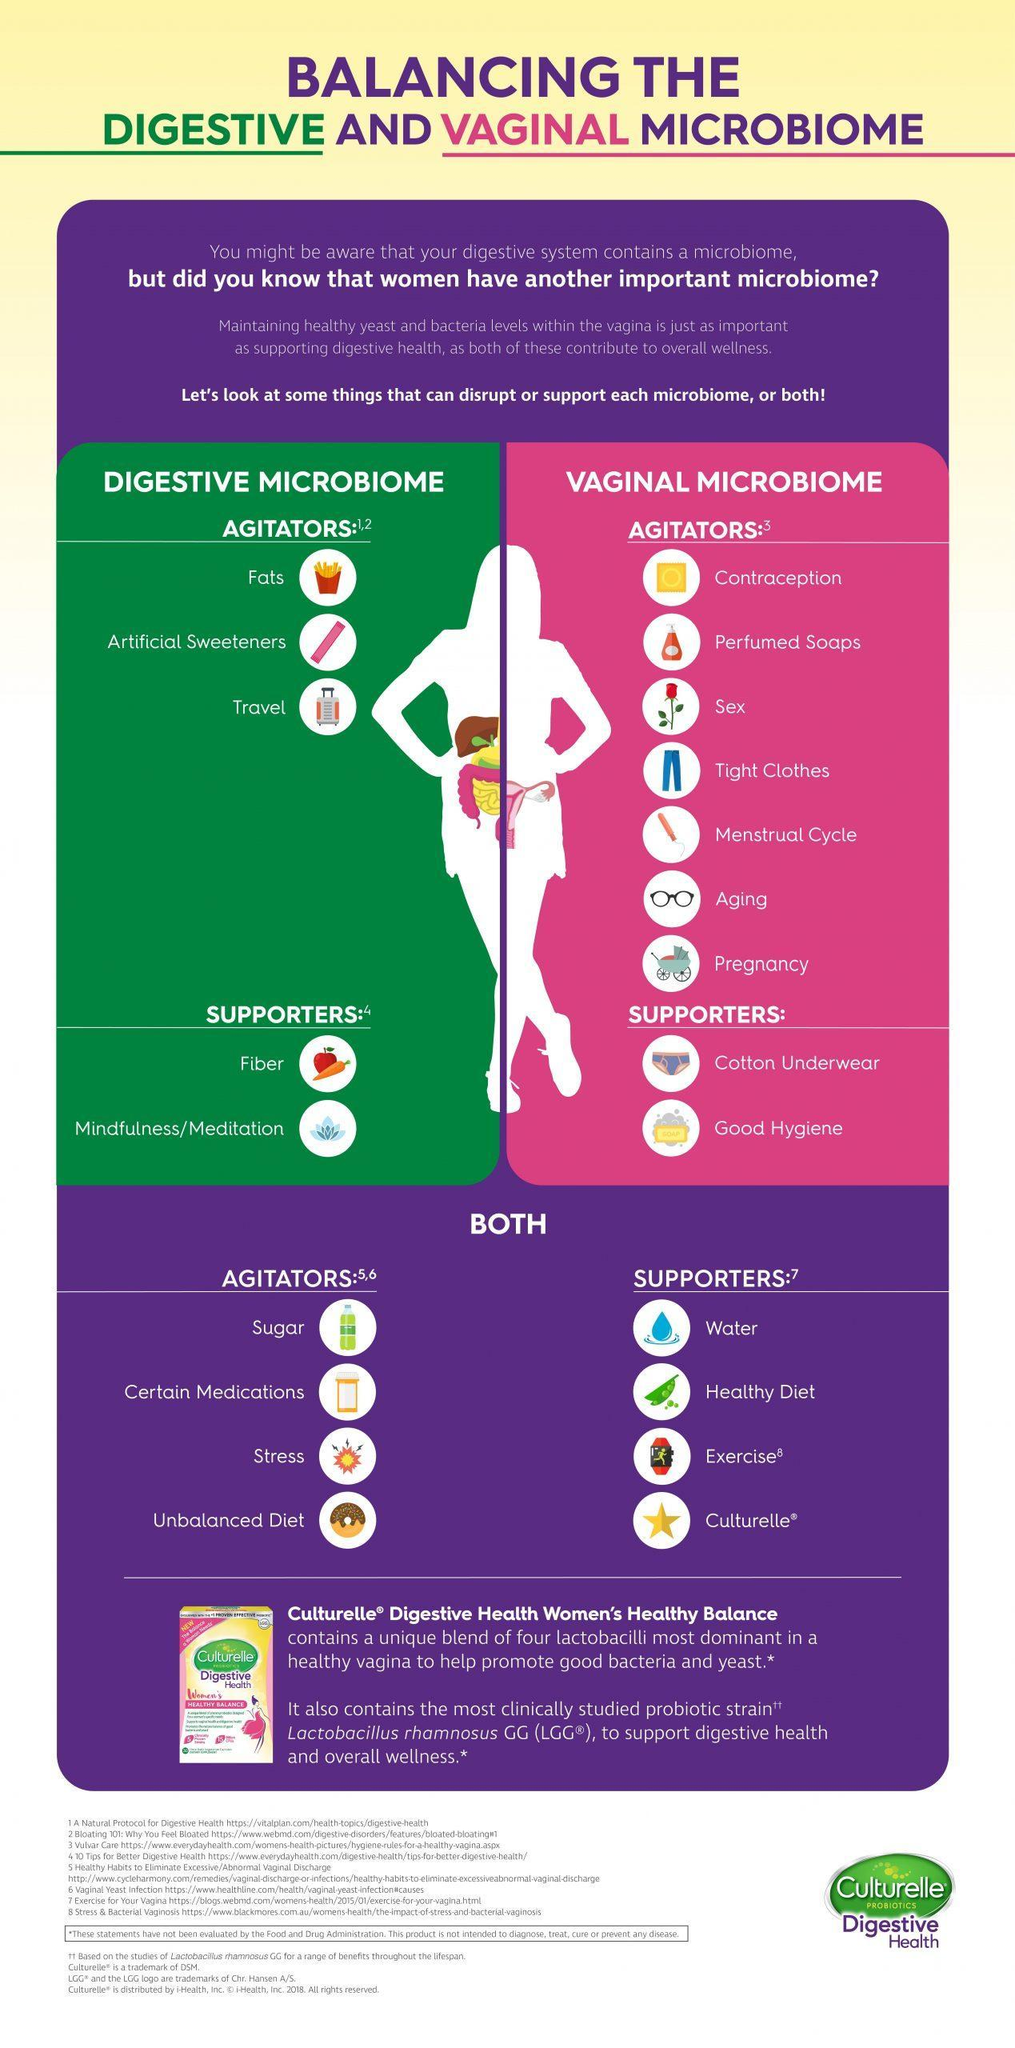What are the supporters of digestive microbiome ?
Answer the question with a short phrase. Fiber, Meditation Which commercial product supports digestive and vaginal microbiome? Culturelle Which are the agitators of digestive microbiome? Fats, Artificial Sweeteners, Travel 